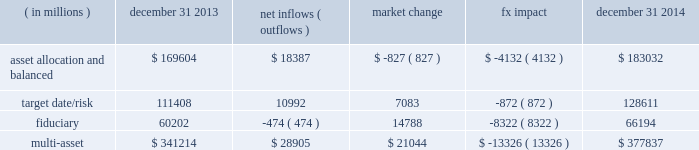Long-term product offerings include active and index strategies .
Our active strategies seek to earn attractive returns in excess of a market benchmark or performance hurdle while maintaining an appropriate risk profile .
We offer two types of active strategies : those that rely primarily on fundamental research and those that utilize primarily quantitative models to drive portfolio construction .
In contrast , index strategies seek to closely track the returns of a corresponding index , generally by investing in substantially the same underlying securities within the index or in a subset of those securities selected to approximate a similar risk and return profile of the index .
Index strategies include both our non-etf index products and ishares etfs .
Althoughmany clients use both active and index strategies , the application of these strategies may differ .
For example , clients may use index products to gain exposure to a market or asset class .
In addition , institutional non-etf index assignments tend to be very large ( multi-billion dollars ) and typically reflect low fee rates .
This has the potential to exaggerate the significance of net flows in institutional index products on blackrock 2019s revenues and earnings .
Equity year-end 2014 equity aum of $ 2.451 trillion increased by $ 133.4 billion , or 6% ( 6 % ) , from the end of 2013 due to net new business of $ 52.4 billion and net market appreciation and foreign exchange movements of $ 81.0 billion .
Net inflows were driven by $ 59.6 billion and $ 17.7 billion into ishares and non-etf index accounts , respectively .
Index inflows were offset by active net outflows of $ 24.9 billion , with outflows of $ 18.0 billion and $ 6.9 billion from fundamental and scientific active equity products , respectively .
Blackrock 2019s effective fee rates fluctuate due to changes in aummix .
Approximately half of blackrock 2019s equity aum is tied to international markets , including emerging markets , which tend to have higher fee rates than similar u.s .
Equity strategies .
Accordingly , fluctuations in international equity markets , which do not consistently move in tandemwith u.s .
Markets , may have a greater impact on blackrock 2019s effective equity fee rates and revenues .
Fixed income fixed income aum ended 2014 at $ 1.394 trillion , increasing $ 151.5 billion , or 12% ( 12 % ) , from december 31 , 2013 .
The increase in aum reflected $ 96.4 billion in net new business and $ 55.1 billion in net market appreciation and foreign exchange movements .
In 2014 , net new business was diversified across fixed income offerings , with strong flows into our unconstrained , total return and high yield products .
Flagship funds in these product areas include our unconstrained strategic income opportunities and fixed income global opportunities funds , with net inflows of $ 13.3 billion and $ 4.2 billion , respectively ; our total return fund with net inflows of $ 2.1 billion ; and our high yield bond fund with net inflows of $ 2.1 billion .
Fixed income net inflows were positive across investment styles , with ishares , non- etf index , and active net inflows of $ 40.0 billion , $ 28.7 billion and $ 27.7 billion , respectively .
Multi-asset class blackrock 2019s multi-asset class teammanages a variety of balanced funds and bespoke mandates for a diversified client base that leverages our broad investment expertise in global equities , currencies , bonds and commodities , and our extensive risk management capabilities .
Investment solutions might include a combination of long-only portfolios and alternative investments as well as tactical asset allocation overlays .
Component changes in multi-asset class aum for 2014 are presented below .
( in millions ) december 31 , 2013 net inflows ( outflows ) market change fx impact december 31 , 2014 .
Flows reflected ongoing institutional demand for our solutions-based advice with $ 15.1 billion , or 52% ( 52 % ) , of net inflows coming from institutional clients .
Defined contribution plans of institutional clients remained a significant driver of flows , and contributed $ 12.8 billion to institutional multi- asset class net new business in 2014 , primarily into target date and target risk product offerings .
Retail net inflows of $ 13.4 billion were driven by particular demand for our multi- asset income fund , which raised $ 6.3 billion in 2014 .
The company 2019s multi-asset strategies include the following : 2022 asset allocation and balanced products represented 48% ( 48 % ) of multi-asset class aum at year-end , with growth in aum driven by net new business of $ 18.4 billion .
These strategies combine equity , fixed income and alternative components for investors seeking a tailored solution relative to a specific benchmark and within a risk budget .
In certain cases , these strategies seek to minimize downside risk through diversification , derivatives strategies and tactical asset allocation decisions .
Flagship products in this category include our global allocation andmulti-asset income suites .
2022 target date and target risk products grew 10% ( 10 % ) organically in 2014 .
Institutional investors represented 90% ( 90 % ) of target date and target risk aum , with defined contribution plans accounting for over 80% ( 80 % ) of aum .
The remaining 10% ( 10 % ) of target date and target risk aum consisted of retail client investments .
Flows were driven by defined contribution investments in our lifepath and lifepath retirement income ae offerings .
Lifepath products utilize a proprietary asset allocation model that seeks to balance risk and return over an investment horizon based on the investor 2019s expected retirement timing .
2022 fiduciary management services are complex mandates in which pension plan sponsors or endowments and foundations retain blackrock to assume responsibility for some or all aspects of planmanagement .
These customized services require strong partnership with the clients 2019 investment staff and trustees in order to tailor investment strategies to meet client-specific risk budgets and return objectives. .
What percent change did the fx impact have on the 2014 multi asset value? 
Computations: (1 - (377837 / (377837 - 13326)))
Answer: -0.03656. Long-term product offerings include active and index strategies .
Our active strategies seek to earn attractive returns in excess of a market benchmark or performance hurdle while maintaining an appropriate risk profile .
We offer two types of active strategies : those that rely primarily on fundamental research and those that utilize primarily quantitative models to drive portfolio construction .
In contrast , index strategies seek to closely track the returns of a corresponding index , generally by investing in substantially the same underlying securities within the index or in a subset of those securities selected to approximate a similar risk and return profile of the index .
Index strategies include both our non-etf index products and ishares etfs .
Althoughmany clients use both active and index strategies , the application of these strategies may differ .
For example , clients may use index products to gain exposure to a market or asset class .
In addition , institutional non-etf index assignments tend to be very large ( multi-billion dollars ) and typically reflect low fee rates .
This has the potential to exaggerate the significance of net flows in institutional index products on blackrock 2019s revenues and earnings .
Equity year-end 2014 equity aum of $ 2.451 trillion increased by $ 133.4 billion , or 6% ( 6 % ) , from the end of 2013 due to net new business of $ 52.4 billion and net market appreciation and foreign exchange movements of $ 81.0 billion .
Net inflows were driven by $ 59.6 billion and $ 17.7 billion into ishares and non-etf index accounts , respectively .
Index inflows were offset by active net outflows of $ 24.9 billion , with outflows of $ 18.0 billion and $ 6.9 billion from fundamental and scientific active equity products , respectively .
Blackrock 2019s effective fee rates fluctuate due to changes in aummix .
Approximately half of blackrock 2019s equity aum is tied to international markets , including emerging markets , which tend to have higher fee rates than similar u.s .
Equity strategies .
Accordingly , fluctuations in international equity markets , which do not consistently move in tandemwith u.s .
Markets , may have a greater impact on blackrock 2019s effective equity fee rates and revenues .
Fixed income fixed income aum ended 2014 at $ 1.394 trillion , increasing $ 151.5 billion , or 12% ( 12 % ) , from december 31 , 2013 .
The increase in aum reflected $ 96.4 billion in net new business and $ 55.1 billion in net market appreciation and foreign exchange movements .
In 2014 , net new business was diversified across fixed income offerings , with strong flows into our unconstrained , total return and high yield products .
Flagship funds in these product areas include our unconstrained strategic income opportunities and fixed income global opportunities funds , with net inflows of $ 13.3 billion and $ 4.2 billion , respectively ; our total return fund with net inflows of $ 2.1 billion ; and our high yield bond fund with net inflows of $ 2.1 billion .
Fixed income net inflows were positive across investment styles , with ishares , non- etf index , and active net inflows of $ 40.0 billion , $ 28.7 billion and $ 27.7 billion , respectively .
Multi-asset class blackrock 2019s multi-asset class teammanages a variety of balanced funds and bespoke mandates for a diversified client base that leverages our broad investment expertise in global equities , currencies , bonds and commodities , and our extensive risk management capabilities .
Investment solutions might include a combination of long-only portfolios and alternative investments as well as tactical asset allocation overlays .
Component changes in multi-asset class aum for 2014 are presented below .
( in millions ) december 31 , 2013 net inflows ( outflows ) market change fx impact december 31 , 2014 .
Flows reflected ongoing institutional demand for our solutions-based advice with $ 15.1 billion , or 52% ( 52 % ) , of net inflows coming from institutional clients .
Defined contribution plans of institutional clients remained a significant driver of flows , and contributed $ 12.8 billion to institutional multi- asset class net new business in 2014 , primarily into target date and target risk product offerings .
Retail net inflows of $ 13.4 billion were driven by particular demand for our multi- asset income fund , which raised $ 6.3 billion in 2014 .
The company 2019s multi-asset strategies include the following : 2022 asset allocation and balanced products represented 48% ( 48 % ) of multi-asset class aum at year-end , with growth in aum driven by net new business of $ 18.4 billion .
These strategies combine equity , fixed income and alternative components for investors seeking a tailored solution relative to a specific benchmark and within a risk budget .
In certain cases , these strategies seek to minimize downside risk through diversification , derivatives strategies and tactical asset allocation decisions .
Flagship products in this category include our global allocation andmulti-asset income suites .
2022 target date and target risk products grew 10% ( 10 % ) organically in 2014 .
Institutional investors represented 90% ( 90 % ) of target date and target risk aum , with defined contribution plans accounting for over 80% ( 80 % ) of aum .
The remaining 10% ( 10 % ) of target date and target risk aum consisted of retail client investments .
Flows were driven by defined contribution investments in our lifepath and lifepath retirement income ae offerings .
Lifepath products utilize a proprietary asset allocation model that seeks to balance risk and return over an investment horizon based on the investor 2019s expected retirement timing .
2022 fiduciary management services are complex mandates in which pension plan sponsors or endowments and foundations retain blackrock to assume responsibility for some or all aspects of planmanagement .
These customized services require strong partnership with the clients 2019 investment staff and trustees in order to tailor investment strategies to meet client-specific risk budgets and return objectives. .
What portion of total multi-asset is related to target date/risk as of december 31 , 2014? 
Computations: (183032 / 377837)
Answer: 0.48442. Long-term product offerings include active and index strategies .
Our active strategies seek to earn attractive returns in excess of a market benchmark or performance hurdle while maintaining an appropriate risk profile .
We offer two types of active strategies : those that rely primarily on fundamental research and those that utilize primarily quantitative models to drive portfolio construction .
In contrast , index strategies seek to closely track the returns of a corresponding index , generally by investing in substantially the same underlying securities within the index or in a subset of those securities selected to approximate a similar risk and return profile of the index .
Index strategies include both our non-etf index products and ishares etfs .
Althoughmany clients use both active and index strategies , the application of these strategies may differ .
For example , clients may use index products to gain exposure to a market or asset class .
In addition , institutional non-etf index assignments tend to be very large ( multi-billion dollars ) and typically reflect low fee rates .
This has the potential to exaggerate the significance of net flows in institutional index products on blackrock 2019s revenues and earnings .
Equity year-end 2014 equity aum of $ 2.451 trillion increased by $ 133.4 billion , or 6% ( 6 % ) , from the end of 2013 due to net new business of $ 52.4 billion and net market appreciation and foreign exchange movements of $ 81.0 billion .
Net inflows were driven by $ 59.6 billion and $ 17.7 billion into ishares and non-etf index accounts , respectively .
Index inflows were offset by active net outflows of $ 24.9 billion , with outflows of $ 18.0 billion and $ 6.9 billion from fundamental and scientific active equity products , respectively .
Blackrock 2019s effective fee rates fluctuate due to changes in aummix .
Approximately half of blackrock 2019s equity aum is tied to international markets , including emerging markets , which tend to have higher fee rates than similar u.s .
Equity strategies .
Accordingly , fluctuations in international equity markets , which do not consistently move in tandemwith u.s .
Markets , may have a greater impact on blackrock 2019s effective equity fee rates and revenues .
Fixed income fixed income aum ended 2014 at $ 1.394 trillion , increasing $ 151.5 billion , or 12% ( 12 % ) , from december 31 , 2013 .
The increase in aum reflected $ 96.4 billion in net new business and $ 55.1 billion in net market appreciation and foreign exchange movements .
In 2014 , net new business was diversified across fixed income offerings , with strong flows into our unconstrained , total return and high yield products .
Flagship funds in these product areas include our unconstrained strategic income opportunities and fixed income global opportunities funds , with net inflows of $ 13.3 billion and $ 4.2 billion , respectively ; our total return fund with net inflows of $ 2.1 billion ; and our high yield bond fund with net inflows of $ 2.1 billion .
Fixed income net inflows were positive across investment styles , with ishares , non- etf index , and active net inflows of $ 40.0 billion , $ 28.7 billion and $ 27.7 billion , respectively .
Multi-asset class blackrock 2019s multi-asset class teammanages a variety of balanced funds and bespoke mandates for a diversified client base that leverages our broad investment expertise in global equities , currencies , bonds and commodities , and our extensive risk management capabilities .
Investment solutions might include a combination of long-only portfolios and alternative investments as well as tactical asset allocation overlays .
Component changes in multi-asset class aum for 2014 are presented below .
( in millions ) december 31 , 2013 net inflows ( outflows ) market change fx impact december 31 , 2014 .
Flows reflected ongoing institutional demand for our solutions-based advice with $ 15.1 billion , or 52% ( 52 % ) , of net inflows coming from institutional clients .
Defined contribution plans of institutional clients remained a significant driver of flows , and contributed $ 12.8 billion to institutional multi- asset class net new business in 2014 , primarily into target date and target risk product offerings .
Retail net inflows of $ 13.4 billion were driven by particular demand for our multi- asset income fund , which raised $ 6.3 billion in 2014 .
The company 2019s multi-asset strategies include the following : 2022 asset allocation and balanced products represented 48% ( 48 % ) of multi-asset class aum at year-end , with growth in aum driven by net new business of $ 18.4 billion .
These strategies combine equity , fixed income and alternative components for investors seeking a tailored solution relative to a specific benchmark and within a risk budget .
In certain cases , these strategies seek to minimize downside risk through diversification , derivatives strategies and tactical asset allocation decisions .
Flagship products in this category include our global allocation andmulti-asset income suites .
2022 target date and target risk products grew 10% ( 10 % ) organically in 2014 .
Institutional investors represented 90% ( 90 % ) of target date and target risk aum , with defined contribution plans accounting for over 80% ( 80 % ) of aum .
The remaining 10% ( 10 % ) of target date and target risk aum consisted of retail client investments .
Flows were driven by defined contribution investments in our lifepath and lifepath retirement income ae offerings .
Lifepath products utilize a proprietary asset allocation model that seeks to balance risk and return over an investment horizon based on the investor 2019s expected retirement timing .
2022 fiduciary management services are complex mandates in which pension plan sponsors or endowments and foundations retain blackrock to assume responsibility for some or all aspects of planmanagement .
These customized services require strong partnership with the clients 2019 investment staff and trustees in order to tailor investment strategies to meet client-specific risk budgets and return objectives. .
What portion of total multi-asset is related to target date/risk as of december 31 , 2013? 
Computations: (111408 / 341214)
Answer: 0.3265. 